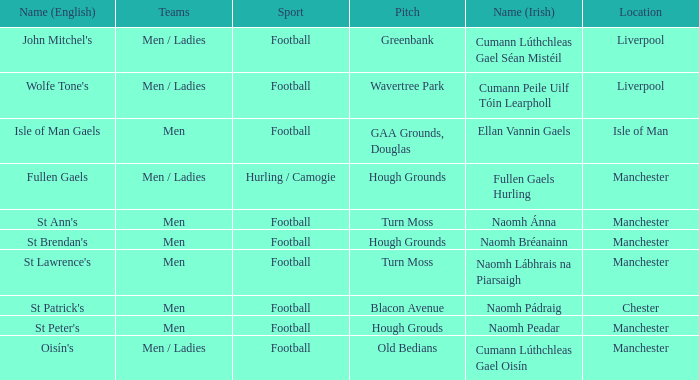What is the Location of the Old Bedians Pitch? Manchester. 